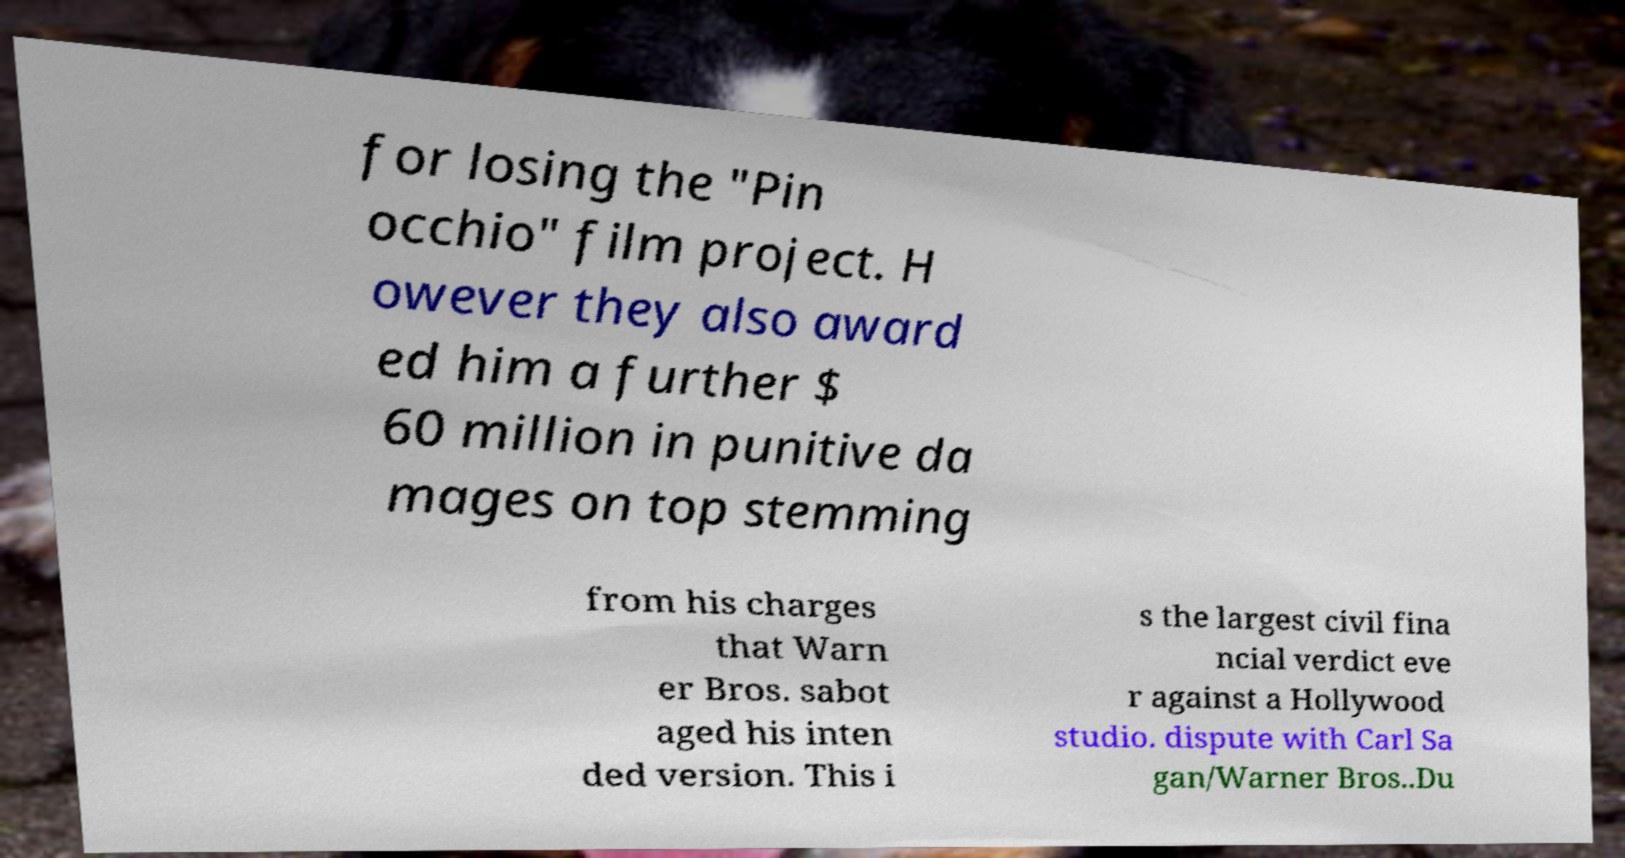Can you accurately transcribe the text from the provided image for me? for losing the "Pin occhio" film project. H owever they also award ed him a further $ 60 million in punitive da mages on top stemming from his charges that Warn er Bros. sabot aged his inten ded version. This i s the largest civil fina ncial verdict eve r against a Hollywood studio. dispute with Carl Sa gan/Warner Bros..Du 